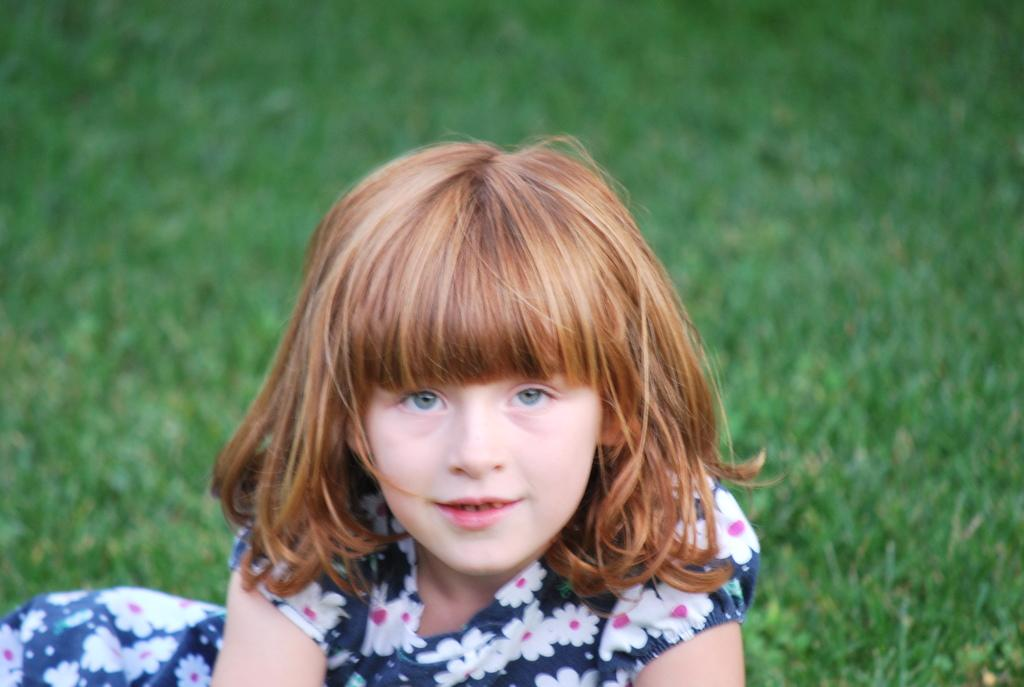What is the main subject of the image? The main subject of the image is a kid. Where is the kid located in the image? The kid is in the center of the image. What is the kid's facial expression? The kid is smiling. What is the kid wearing? The kid is wearing a multiple color dress. What can be seen in the background of the image? There is grass visible in the background of the image. What type of stitch is the kid using to sew a button on their dress in the image? There is no indication in the image that the kid is sewing a button or using any stitch. 